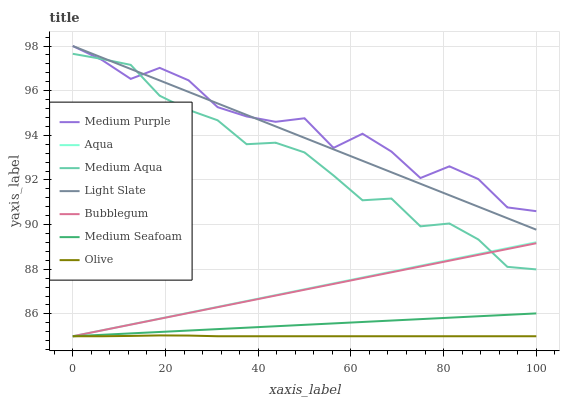Does Olive have the minimum area under the curve?
Answer yes or no. Yes. Does Medium Purple have the maximum area under the curve?
Answer yes or no. Yes. Does Aqua have the minimum area under the curve?
Answer yes or no. No. Does Aqua have the maximum area under the curve?
Answer yes or no. No. Is Medium Seafoam the smoothest?
Answer yes or no. Yes. Is Medium Purple the roughest?
Answer yes or no. Yes. Is Aqua the smoothest?
Answer yes or no. No. Is Aqua the roughest?
Answer yes or no. No. Does Aqua have the lowest value?
Answer yes or no. Yes. Does Medium Purple have the lowest value?
Answer yes or no. No. Does Medium Purple have the highest value?
Answer yes or no. Yes. Does Aqua have the highest value?
Answer yes or no. No. Is Aqua less than Light Slate?
Answer yes or no. Yes. Is Medium Purple greater than Aqua?
Answer yes or no. Yes. Does Medium Aqua intersect Bubblegum?
Answer yes or no. Yes. Is Medium Aqua less than Bubblegum?
Answer yes or no. No. Is Medium Aqua greater than Bubblegum?
Answer yes or no. No. Does Aqua intersect Light Slate?
Answer yes or no. No. 